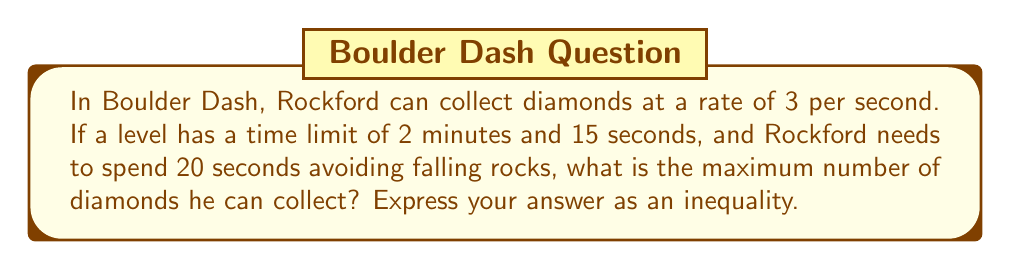Could you help me with this problem? Let's approach this step-by-step:

1) First, we need to convert the total time limit to seconds:
   2 minutes and 15 seconds = (2 × 60) + 15 = 135 seconds

2) Now, we subtract the time spent avoiding rocks:
   Available time for collecting diamonds = 135 - 20 = 115 seconds

3) We know Rockford can collect 3 diamonds per second. Let's call the number of diamonds he can collect $x$. We can set up the following equation:
   
   $$x = 3 \times 115 = 345$$

4) However, since we're asked for an inequality, we need to consider that Rockford might not be able to collect diamonds continuously without any interruption. Therefore, the actual number of diamonds collected will be less than or equal to this calculated maximum.

5) We can express this as an inequality:

   $$x \leq 345$$

This inequality represents the maximum number of diamonds Rockford can collect under the given conditions.
Answer: $x \leq 345$ 